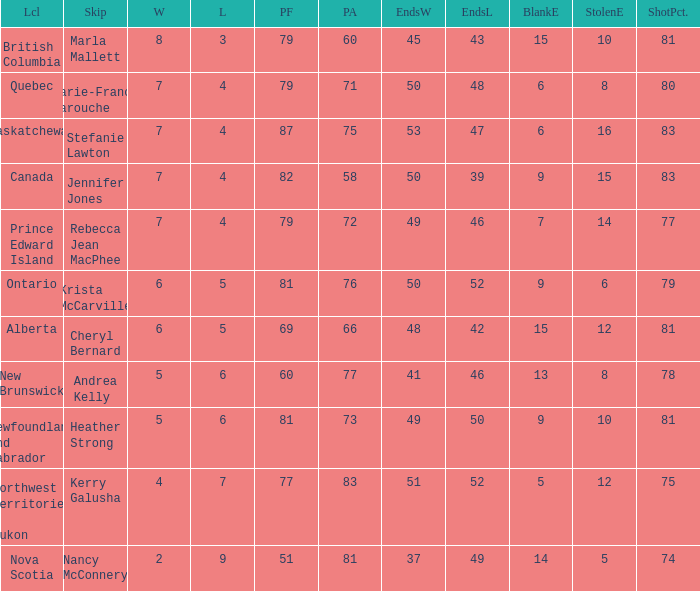What is the pf for Rebecca Jean Macphee? 79.0. 